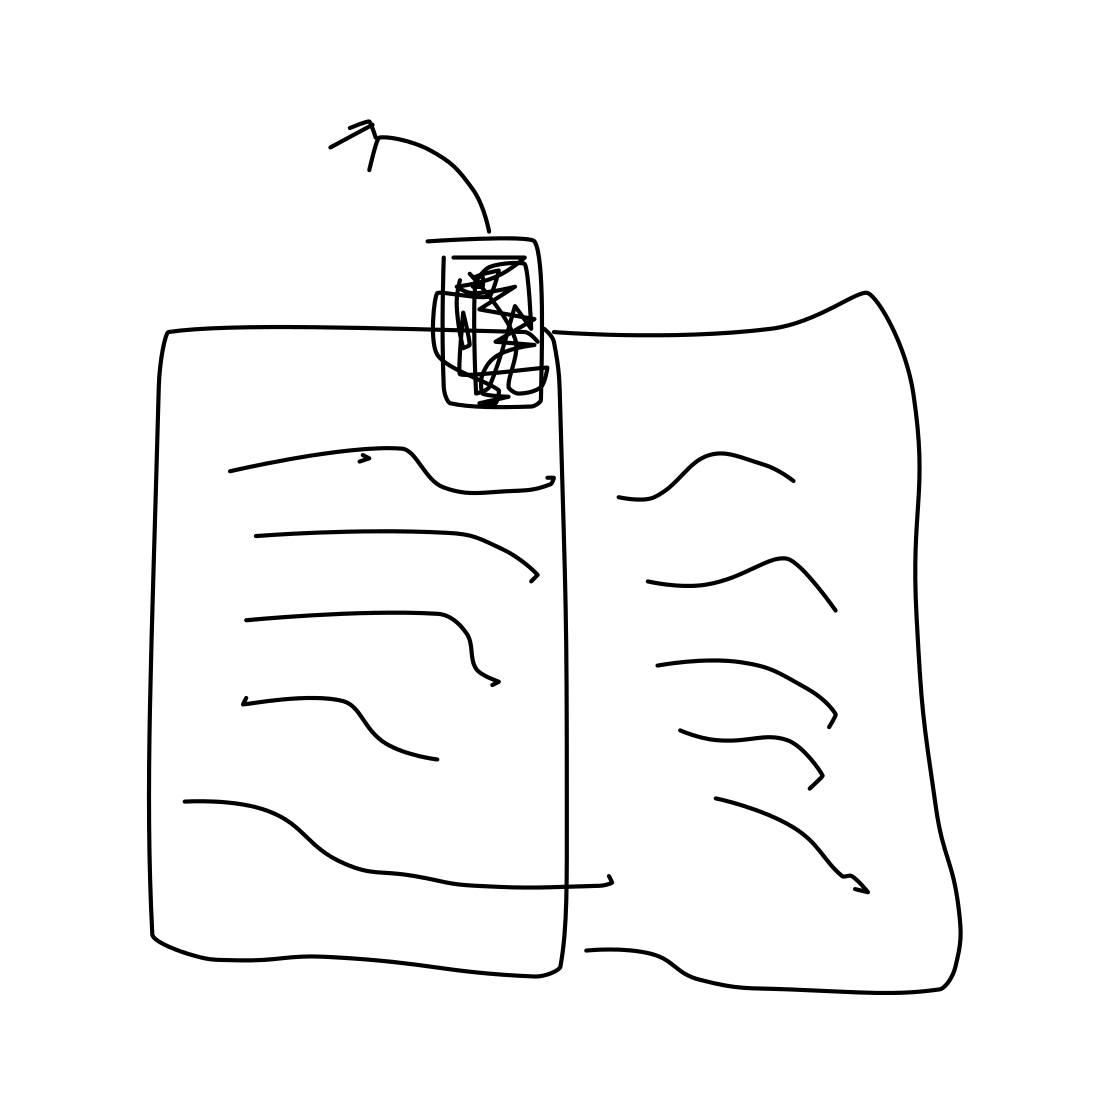Can you tell me what might be written on the pages? While the specific content on the pages is indiscernible due to the lack of clear details, the lines suggest text or some form of organized notation, which could range from literature to academic text. 